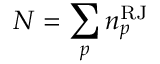Convert formula to latex. <formula><loc_0><loc_0><loc_500><loc_500>N = \sum _ { p } n _ { p } ^ { R J }</formula> 